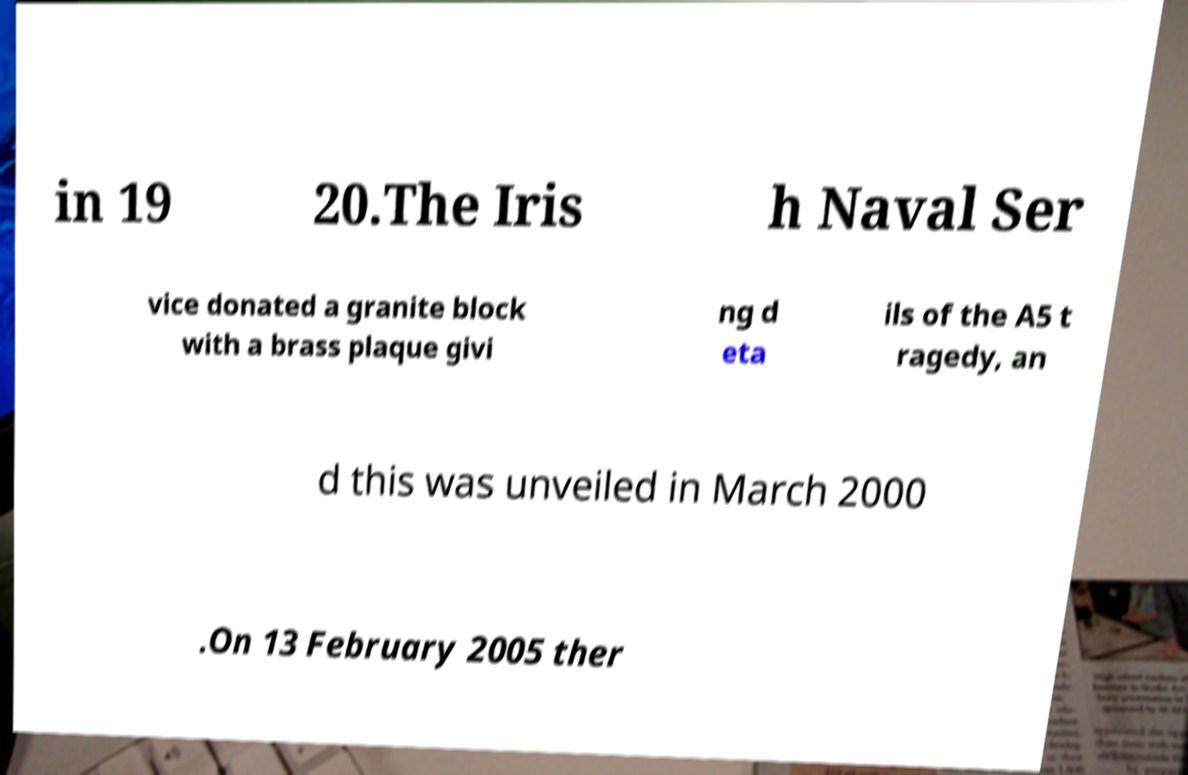What messages or text are displayed in this image? I need them in a readable, typed format. in 19 20.The Iris h Naval Ser vice donated a granite block with a brass plaque givi ng d eta ils of the A5 t ragedy, an d this was unveiled in March 2000 .On 13 February 2005 ther 